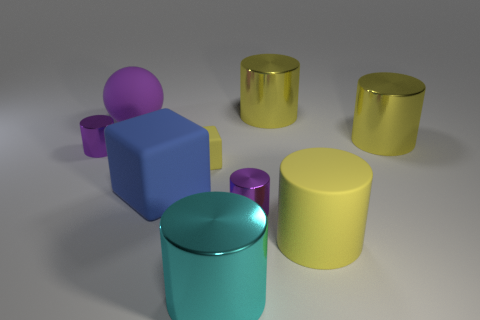Subtract all shiny cylinders. How many cylinders are left? 1 Subtract all gray balls. How many yellow cylinders are left? 3 Subtract all yellow cylinders. How many cylinders are left? 3 Subtract 2 cylinders. How many cylinders are left? 4 Subtract all blocks. How many objects are left? 7 Subtract all cylinders. Subtract all cyan metal cubes. How many objects are left? 3 Add 8 cyan objects. How many cyan objects are left? 9 Add 8 blue matte cubes. How many blue matte cubes exist? 9 Subtract 0 red cylinders. How many objects are left? 9 Subtract all red cylinders. Subtract all yellow balls. How many cylinders are left? 6 